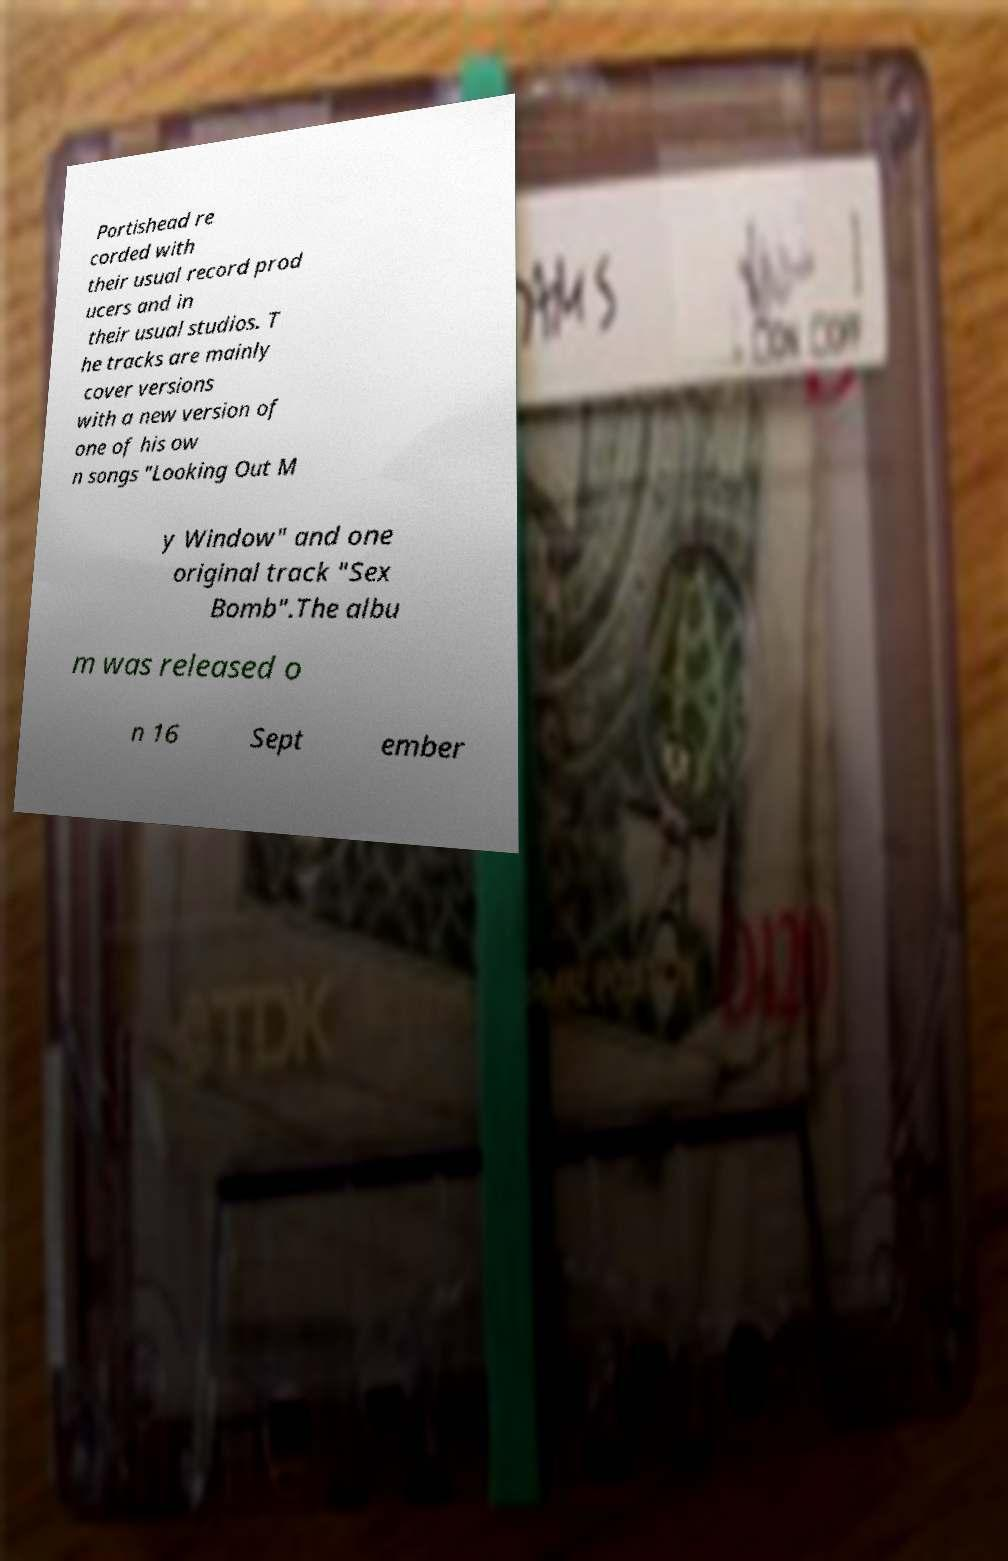I need the written content from this picture converted into text. Can you do that? Portishead re corded with their usual record prod ucers and in their usual studios. T he tracks are mainly cover versions with a new version of one of his ow n songs "Looking Out M y Window" and one original track "Sex Bomb".The albu m was released o n 16 Sept ember 